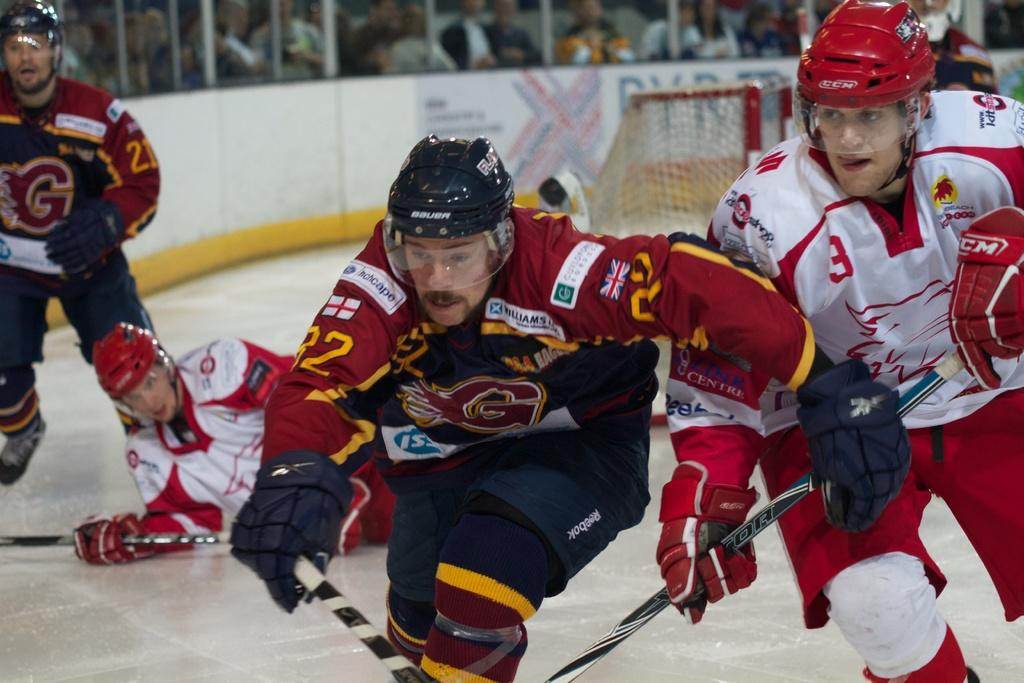How many people are in the image? There are persons in the image. What are the persons wearing? The persons are wearing clothes. What activity are the persons engaged in? The persons are playing ice hockey. What is the background of the image? There is a wall at the top of the image. What type of respect can be seen between the persons in the image? There is no indication of respect between the persons in the image, as they are playing ice hockey. What relation do the persons in the image have to each other? There is no information about the relation between the persons in the image. 